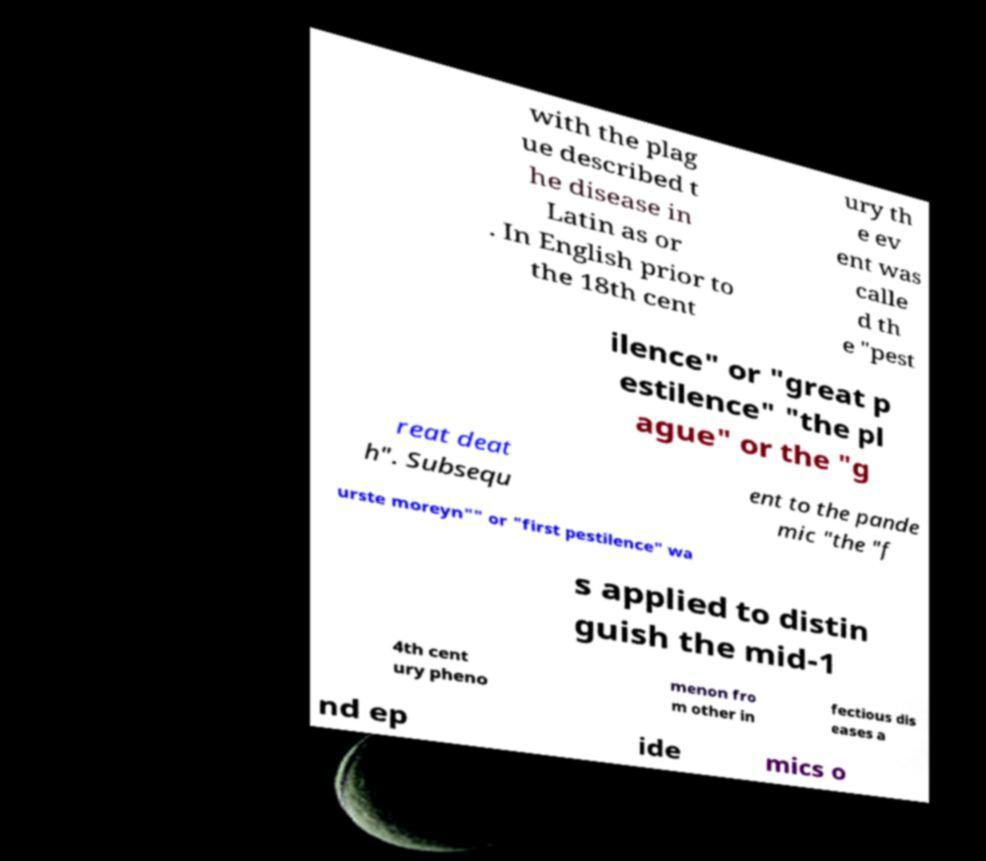Could you extract and type out the text from this image? with the plag ue described t he disease in Latin as or . In English prior to the 18th cent ury th e ev ent was calle d th e "pest ilence" or "great p estilence" "the pl ague" or the "g reat deat h". Subsequ ent to the pande mic "the "f urste moreyn"" or "first pestilence" wa s applied to distin guish the mid-1 4th cent ury pheno menon fro m other in fectious dis eases a nd ep ide mics o 